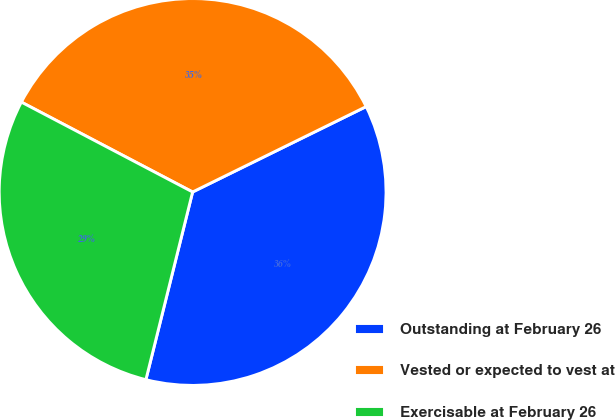Convert chart to OTSL. <chart><loc_0><loc_0><loc_500><loc_500><pie_chart><fcel>Outstanding at February 26<fcel>Vested or expected to vest at<fcel>Exercisable at February 26<nl><fcel>36.16%<fcel>35.03%<fcel>28.81%<nl></chart> 